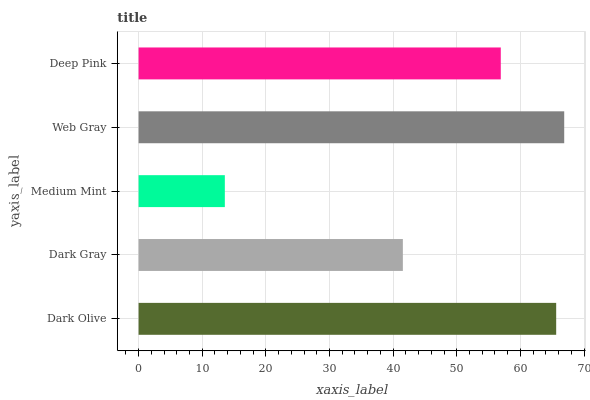Is Medium Mint the minimum?
Answer yes or no. Yes. Is Web Gray the maximum?
Answer yes or no. Yes. Is Dark Gray the minimum?
Answer yes or no. No. Is Dark Gray the maximum?
Answer yes or no. No. Is Dark Olive greater than Dark Gray?
Answer yes or no. Yes. Is Dark Gray less than Dark Olive?
Answer yes or no. Yes. Is Dark Gray greater than Dark Olive?
Answer yes or no. No. Is Dark Olive less than Dark Gray?
Answer yes or no. No. Is Deep Pink the high median?
Answer yes or no. Yes. Is Deep Pink the low median?
Answer yes or no. Yes. Is Dark Gray the high median?
Answer yes or no. No. Is Web Gray the low median?
Answer yes or no. No. 